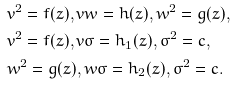Convert formula to latex. <formula><loc_0><loc_0><loc_500><loc_500>& v ^ { 2 } = f ( z ) , v w = h ( z ) , w ^ { 2 } = g ( z ) , \\ & v ^ { 2 } = f ( z ) , v \sigma = h _ { 1 } ( z ) , \sigma ^ { 2 } = c , \\ & w ^ { 2 } = g ( z ) , w \sigma = h _ { 2 } ( z ) , \sigma ^ { 2 } = c .</formula> 